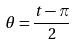Convert formula to latex. <formula><loc_0><loc_0><loc_500><loc_500>\theta = \frac { t - \pi } { 2 }</formula> 